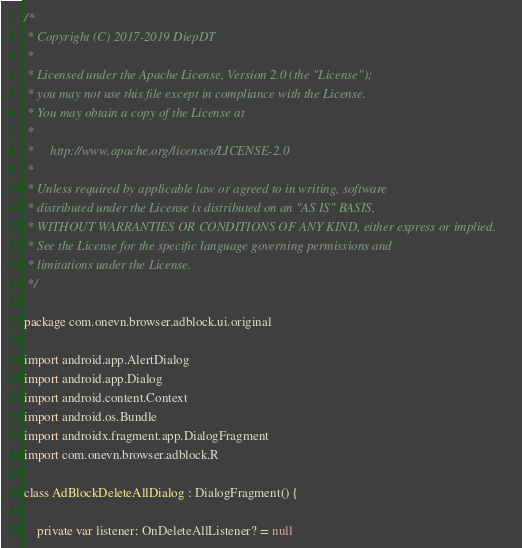Convert code to text. <code><loc_0><loc_0><loc_500><loc_500><_Kotlin_>/*
 * Copyright (C) 2017-2019 DiepDT
 *
 * Licensed under the Apache License, Version 2.0 (the "License");
 * you may not use this file except in compliance with the License.
 * You may obtain a copy of the License at
 *
 *     http://www.apache.org/licenses/LICENSE-2.0
 *
 * Unless required by applicable law or agreed to in writing, software
 * distributed under the License is distributed on an "AS IS" BASIS,
 * WITHOUT WARRANTIES OR CONDITIONS OF ANY KIND, either express or implied.
 * See the License for the specific language governing permissions and
 * limitations under the License.
 */

package com.onevn.browser.adblock.ui.original

import android.app.AlertDialog
import android.app.Dialog
import android.content.Context
import android.os.Bundle
import androidx.fragment.app.DialogFragment
import com.onevn.browser.adblock.R

class AdBlockDeleteAllDialog : DialogFragment() {

    private var listener: OnDeleteAllListener? = null
</code> 